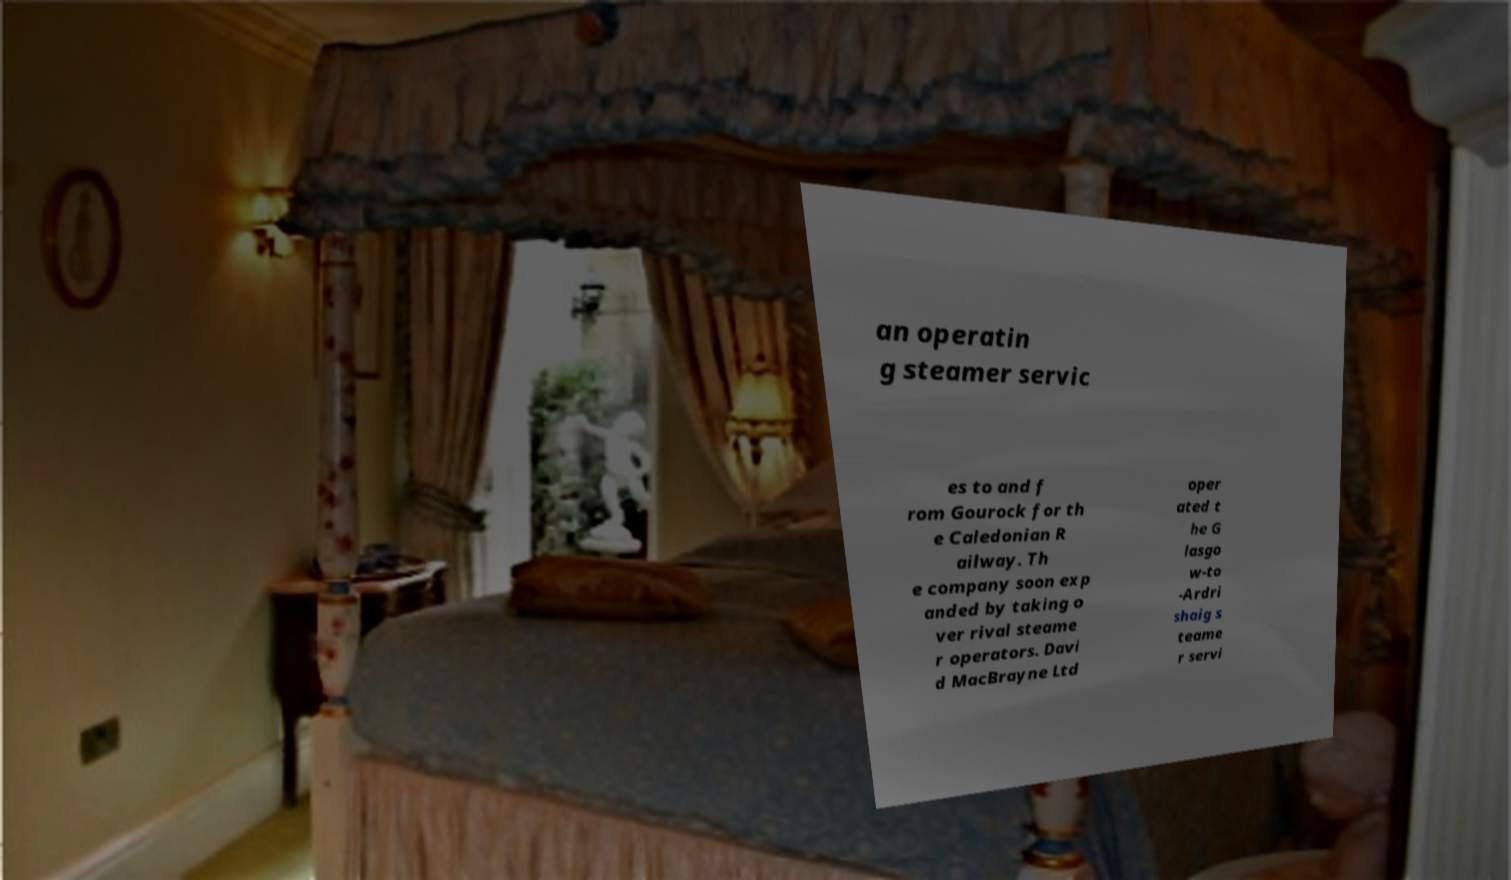Could you assist in decoding the text presented in this image and type it out clearly? an operatin g steamer servic es to and f rom Gourock for th e Caledonian R ailway. Th e company soon exp anded by taking o ver rival steame r operators. Davi d MacBrayne Ltd oper ated t he G lasgo w-to -Ardri shaig s teame r servi 